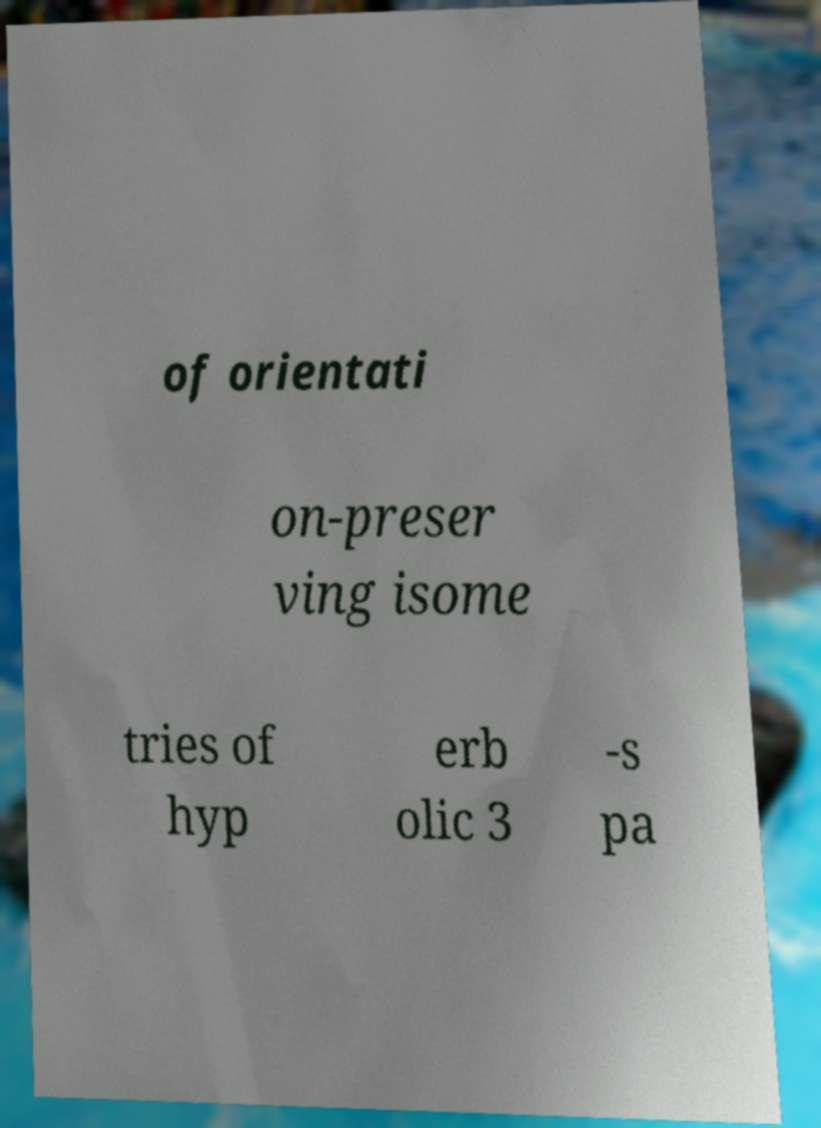Can you accurately transcribe the text from the provided image for me? of orientati on-preser ving isome tries of hyp erb olic 3 -s pa 